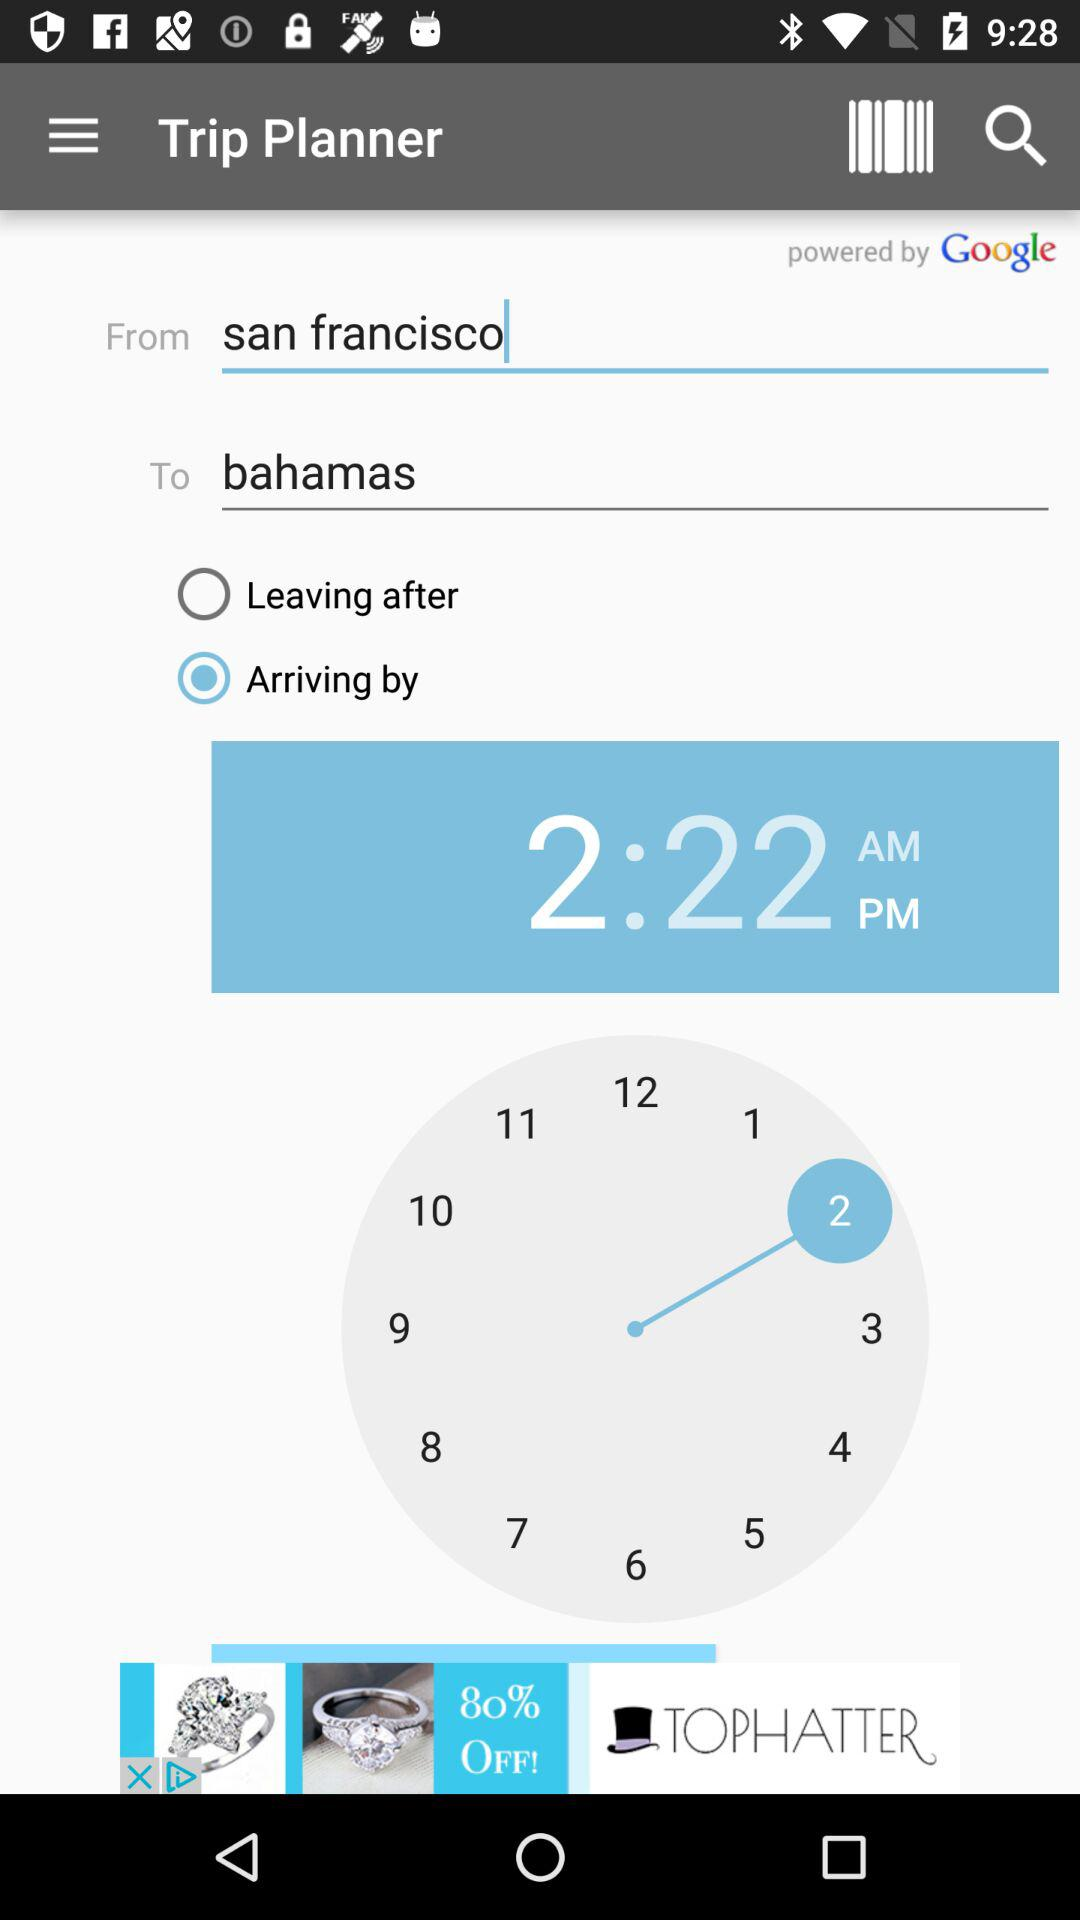What is the destination? The destination is the Bahamas. 